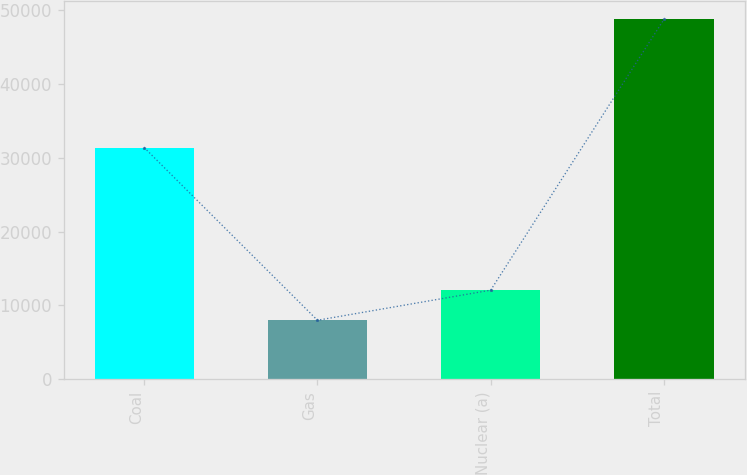<chart> <loc_0><loc_0><loc_500><loc_500><bar_chart><fcel>Coal<fcel>Gas<fcel>Nuclear (a)<fcel>Total<nl><fcel>31371<fcel>7983<fcel>12058.6<fcel>48739<nl></chart> 